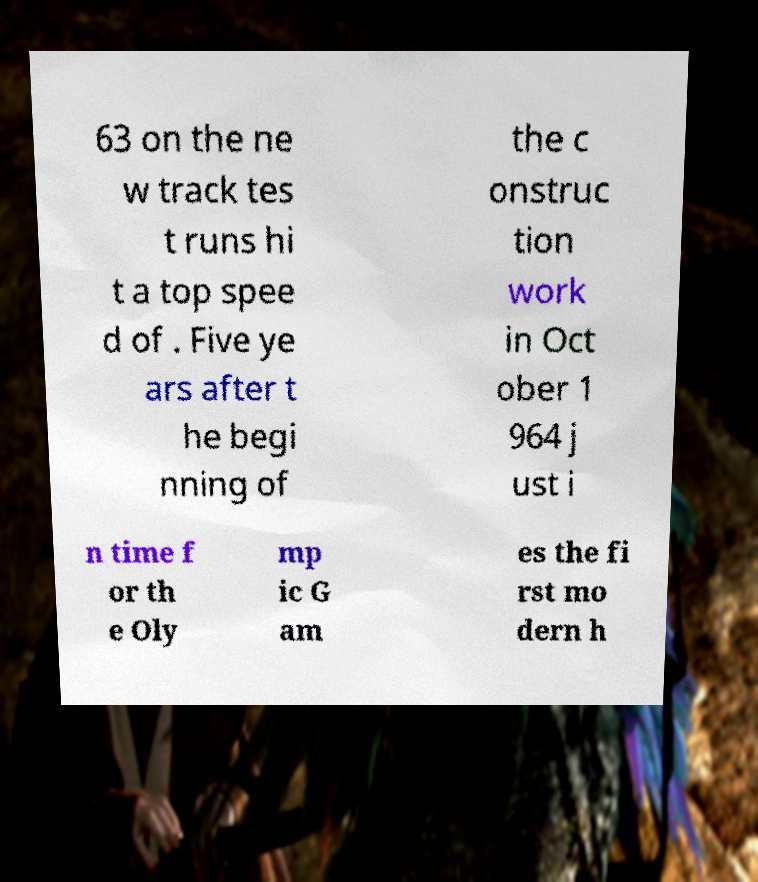There's text embedded in this image that I need extracted. Can you transcribe it verbatim? 63 on the ne w track tes t runs hi t a top spee d of . Five ye ars after t he begi nning of the c onstruc tion work in Oct ober 1 964 j ust i n time f or th e Oly mp ic G am es the fi rst mo dern h 